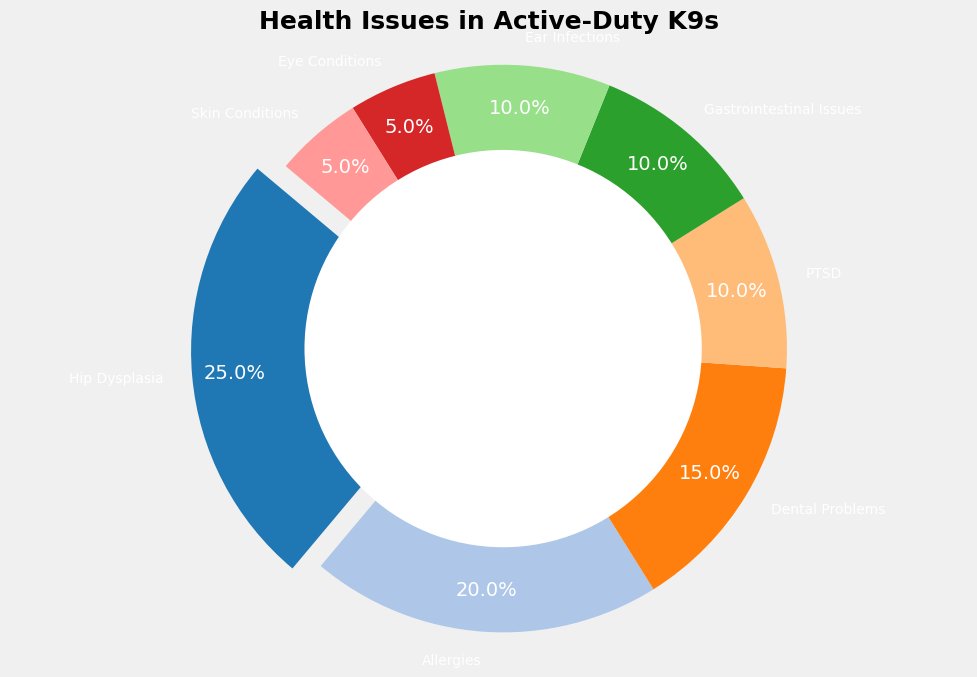Which health issue affects the highest percentage of active-duty K9s? By examining the visual emphasis in the pie chart, where the largest slice is exploded, we can identify "Hip Dysplasia" as the health issue with the largest percentage.
Answer: Hip Dysplasia What is the combined percentage of K9s affected by Gastrointestinal Issues and Ear Infections? By adding the percentages of Gastrointestinal Issues (10%) and Ear Infections (10%), we find the combined percentage.
Answer: 20% Which two health issues have the lowest occurrence among active-duty K9s? By identifying the smallest slices on the pie chart, we can determine that "Eye Conditions" and "Skin Conditions" each represent the lowest percentage (5% each).
Answer: Eye Conditions and Skin Conditions How much larger is the percentage of K9s with Allergies compared to those with PTSD? Subtract the percentage of K9s with PTSD (10%) from those with Allergies (20%).
Answer: 10% What percentage of active-duty K9s are affected by conditions related to the eyes and ears combined? Add the percentages for Eye Conditions (5%) and Ear Infections (10%) to find the combined total.
Answer: 15% Which health issue is more prevalent, Dental Problems or PTSD? Compare the percentage of K9s with Dental Problems (15%) to those with PTSD (10%).
Answer: Dental Problems How many health issues affect 10% of active-duty K9s? By counting the segments in the pie chart that each represent 10%, we find Gastrointestinal Issues, Ear Infections, and PTSD.
Answer: 3 Of the health issues listed, which one represents the exact middle value when ranked by percentage? When the percentages are ranked, the middle values are 10% (Gastrointestinal Issues, PTSD, and Ear Infections), so any of these can be considered a middle value.
Answer: Gastrointestinal Issues What is the total percentage of K9s affected by the three most common health issues? Add the percentages of the three largest segments: Hip Dysplasia (25%), Allergies (20%), and Dental Problems (15%).
Answer: 60% Which segment is colored differently to emphasize its importance and why is this done? The segment representing Hip Dysplasia is exploded outwards compared to the others to highlight it as the most common health issue.
Answer: Hip Dysplasia 